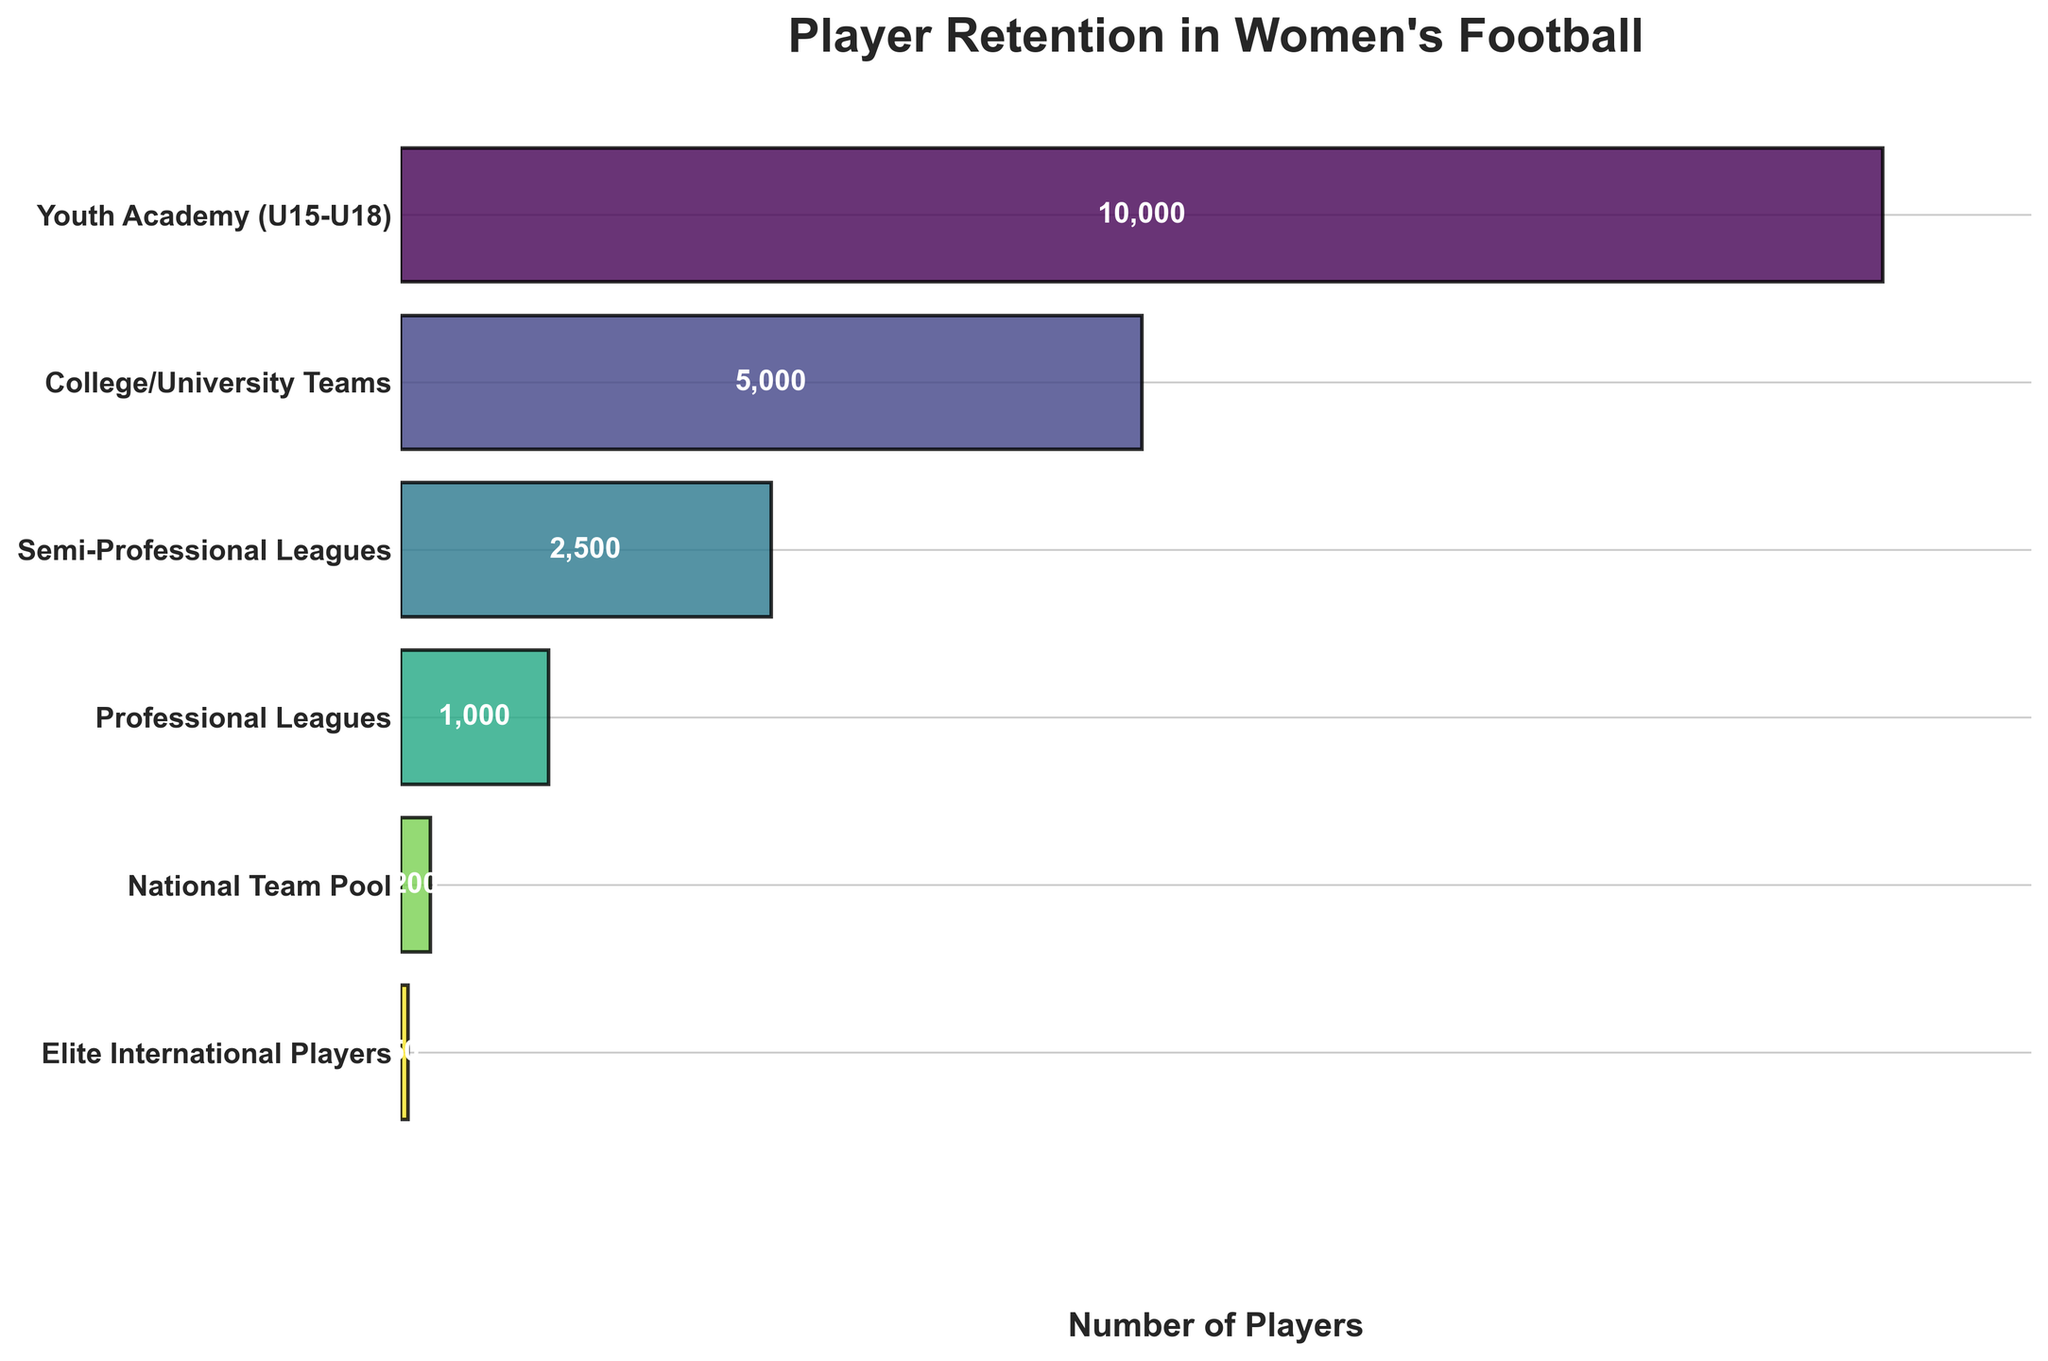What's the title of the figure? The title of the figure is always displayed at the top of the chart. It's typically in a larger font size to indicate its importance.
Answer: Player Retention in Women's Football How many stages are there in the chart? The stages can be observed as the labeled sections along the y-axis of the chart. By counting these labels, we determine the number of stages presented.
Answer: 6 Which stage has the highest number of players? By looking at the length of the bars, the bar corresponding to the stage with the greatest length indicates the highest number of players.
Answer: Youth Academy (U15-U18) What percentage of players progress from Semi-Professional Leagues to Professional Leagues? To find the percentage, divide the number of players in Professional Leagues (1000) by the number of players in Semi-Professional Leagues (2500) and multiply by 100.
Answer: 40% What is the drop-off in the number of players from Youth Academy to College/University Teams? Subtract the number of players in College/University Teams (5000) from the number of players in Youth Academy (10000).
Answer: 5000 players Which stage shows the second-largest decrease in player retention? Calculate the difference in the number of players between each consecutive stage. Identify the second-largest decrease.
Answer: College/University Teams to Semi-Professional Leagues How does the drop-off from the Semi-Professional Leagues to the Professional Leagues compare to the drop-off from Professional Leagues to the National Team Pool? Calculate the drop-offs for both stages. From Semi-Professional Leagues to Professional Leagues: 2500 - 1000 = 1500. From Professional Leagues to National Team Pool: 1000 - 200 = 800. Compare these differences.
Answer: 1500 vs 800 What's the ratio of Elite International Players to National Team Pool players? Divide the number of players in Elite International Players (50) by the number of players in National Team Pool (200).
Answer: 1:4 What is the cumulative number of players from the Professional Leagues to the Elite International Players? Add the number of players in the Professional Leagues, National Team Pool, and Elite International Players (1000 + 200 + 50).
Answer: 1250 